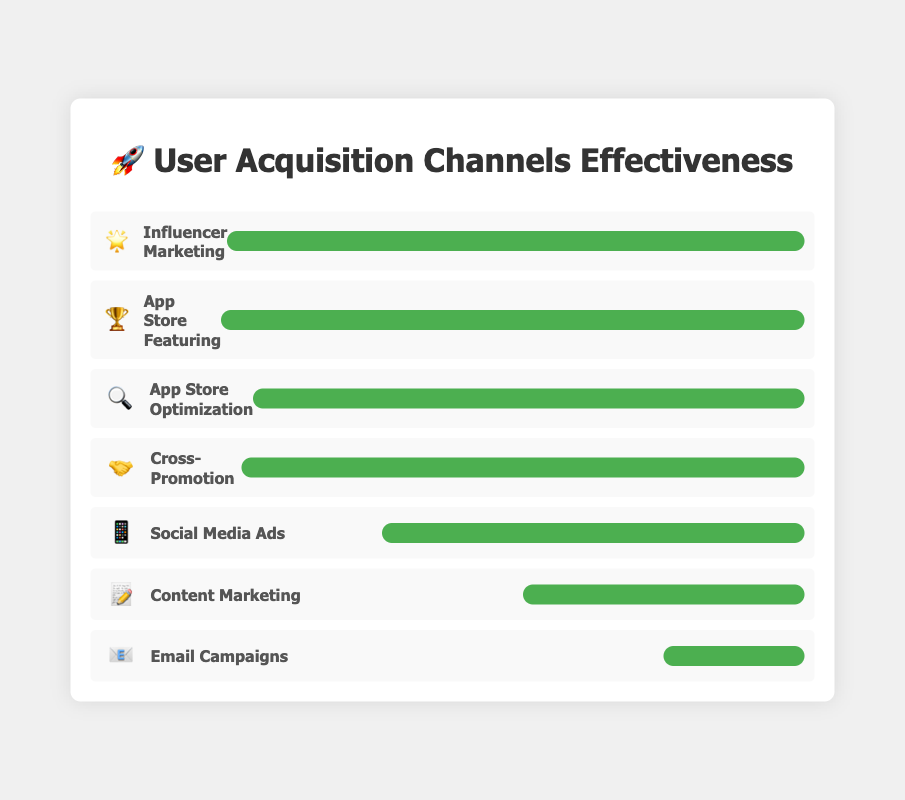Which channel has the highest effectiveness? The figure shows bars representing the effectiveness of each channel. Influencer Marketing 🌟 and App Store Featuring 🏆 have the highest bars, indicating that they are the most effective with a score of 5.
Answer: Influencer Marketing and App Store Featuring Which channel uses the 📧 emoji, and how effective is it? By looking at the chart, we can see that Email Campaigns are associated with the 📧 emoji. The width of the bar for Email Campaigns indicates an effectiveness of 1.
Answer: Email Campaigns, effectiveness of 1 How many channels have an effectiveness score of 4 or higher? By visually examining the lengths of the effectiveness bars, we see that App Store Optimization 🔍, Influencer Marketing 🌟, Cross-Promotion 🤝, and App Store Featuring 🏆 all have scores of 4 or higher. This accounts for 4 channels.
Answer: 4 channels What is the average effectiveness score across all channels? To calculate the average, sum up all the effectiveness scores (4 + 3 + 5 + 2 + 4 + 1 + 5 = 24) and divide by the number of channels (7). The average is 24 / 7 ≈ 3.43.
Answer: 3.43 Which two channels have an effectiveness of 5? By looking at the chart, we can see which bars are fully extended, representing an effectiveness of 5. Both Influencer Marketing 🌟 and App Store Featuring 🏆 have bars indicating an effectiveness of 5.
Answer: Influencer Marketing and App Store Featuring Which channels have a lower effectiveness than Social Media Ads 📱? Social Media Ads 📱 have an effectiveness of 3. By comparing bars shorter than this, we see that Content Marketing 📝 and Email Campaigns 📧 have effectiveness scores of 2 and 1, respectively.
Answer: Content Marketing and Email Campaigns Which effectiveness score is shared by the most channels? By scanning the bars, we see that an effectiveness score of 4 is held by App Store Optimization 🔍 and Cross-Promotion 🤝, making it the most common score among the channels in this chart.
Answer: 4 How does the effectiveness of Content Marketing compare to Email Campaigns? Observing the bars for these two channels, Content Marketing 📝 has an effectiveness of 2, and Email Campaigns 📧 has an effectiveness of 1. Thus, Content Marketing is more effective than Email Campaigns.
Answer: Content Marketing is more effective Are there more channels with an effectiveness less than 4 or greater than 4? Channels with effectiveness less than 4: Social Media Ads 📱 (3), Content Marketing 📝 (2), Email Campaigns 📧 (1) – 3 channels.
Channels with effectiveness greater than 4: Influencer Marketing 🌟 (5), App Store Featuring 🏆 (5) – 2 channels.
Less than 4 channels are more.
Answer: Less than 4 If a new channel were added with an effectiveness of 3, how would it affect the chart's average effectiveness? Adding a new channel with effectiveness 3 changes totals: (4 + 3 + 5 + 2 + 4 + 1 + 5 + 3 = 27 for 8 channels). New average: 27 / 8 = 3.375.
Answer: 3.375 